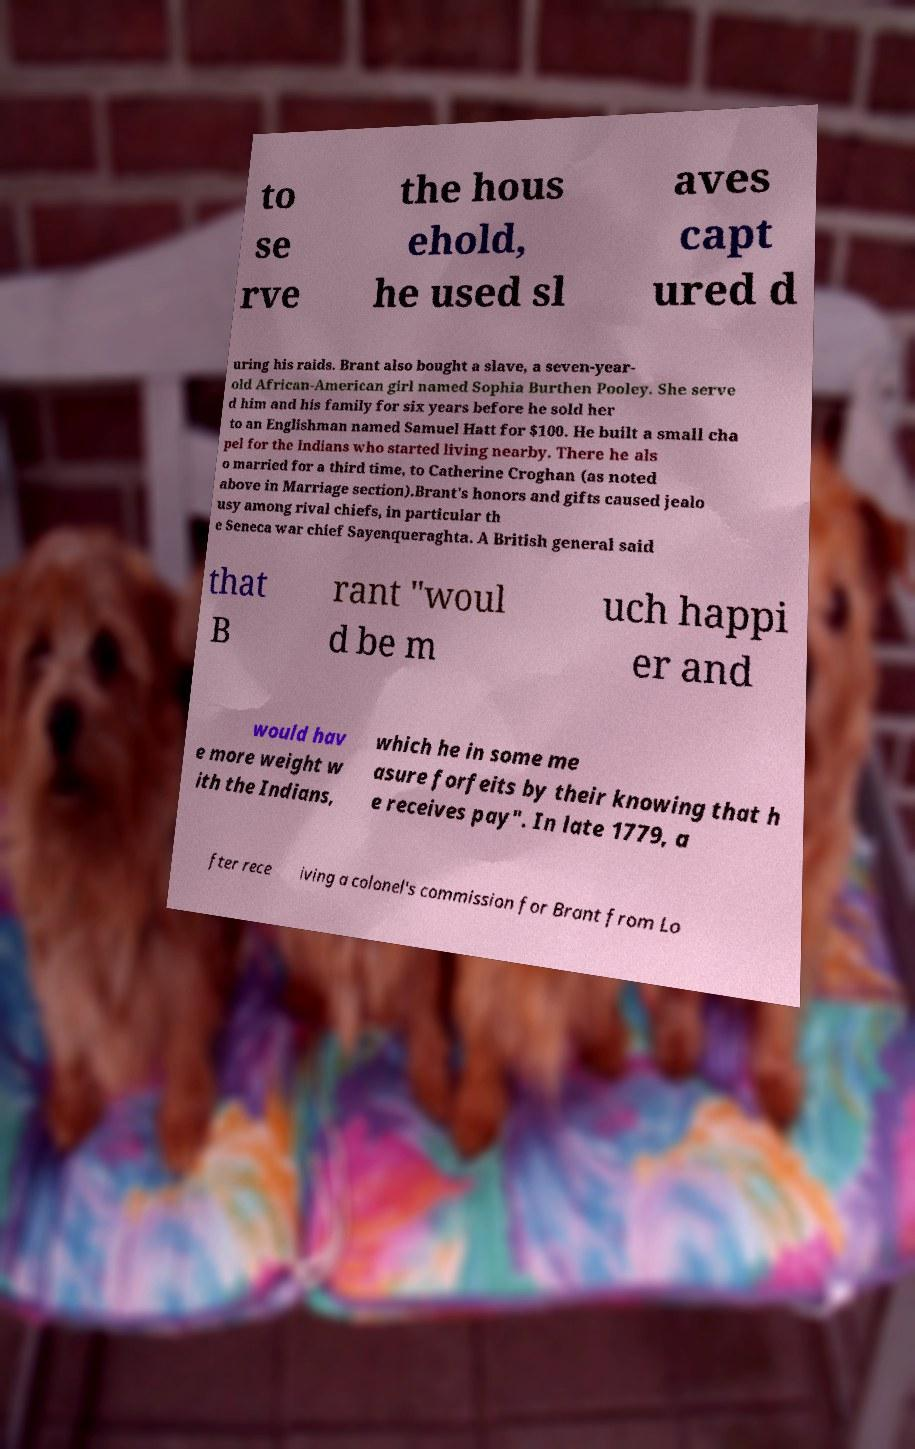There's text embedded in this image that I need extracted. Can you transcribe it verbatim? to se rve the hous ehold, he used sl aves capt ured d uring his raids. Brant also bought a slave, a seven-year- old African-American girl named Sophia Burthen Pooley. She serve d him and his family for six years before he sold her to an Englishman named Samuel Hatt for $100. He built a small cha pel for the Indians who started living nearby. There he als o married for a third time, to Catherine Croghan (as noted above in Marriage section).Brant's honors and gifts caused jealo usy among rival chiefs, in particular th e Seneca war chief Sayenqueraghta. A British general said that B rant "woul d be m uch happi er and would hav e more weight w ith the Indians, which he in some me asure forfeits by their knowing that h e receives pay". In late 1779, a fter rece iving a colonel's commission for Brant from Lo 